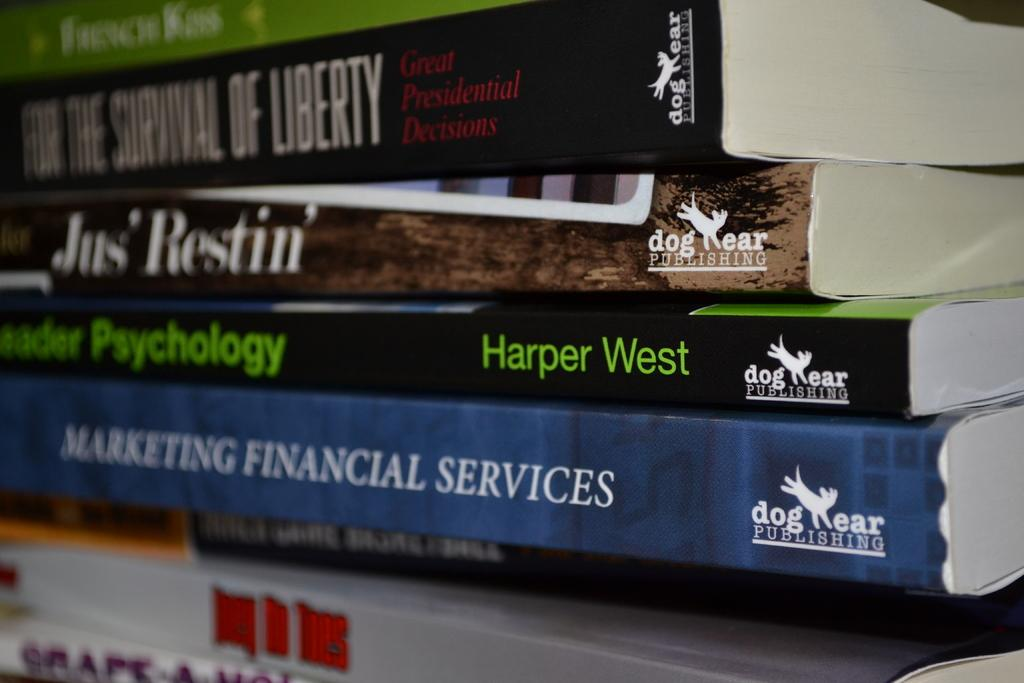<image>
Describe the image concisely. A big stack of different books, all published by Dog Ear Publishing. 